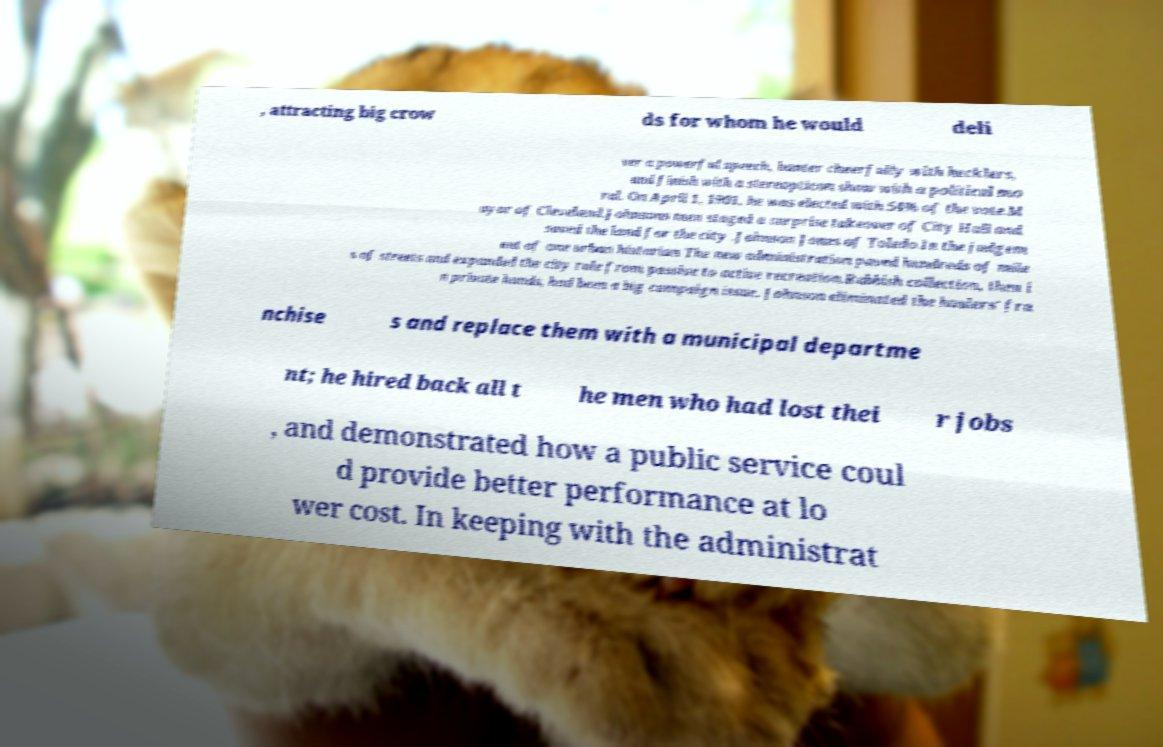Can you accurately transcribe the text from the provided image for me? , attracting big crow ds for whom he would deli ver a powerful speech, banter cheerfully with hecklers, and finish with a stereopticon show with a political mo ral. On April 1, 1901, he was elected with 54% of the vote.M ayor of Cleveland.Johnsons men staged a surprise takeover of City Hall and saved the land for the city .Johnson Jones of Toledo.In the judgem ent of one urban historian The new administration paved hundreds of mile s of streets and expanded the city role from passive to active recreation.Rubbish collection, then i n private hands, had been a big campaign issue. Johnson eliminated the haulers' fra nchise s and replace them with a municipal departme nt; he hired back all t he men who had lost thei r jobs , and demonstrated how a public service coul d provide better performance at lo wer cost. In keeping with the administrat 